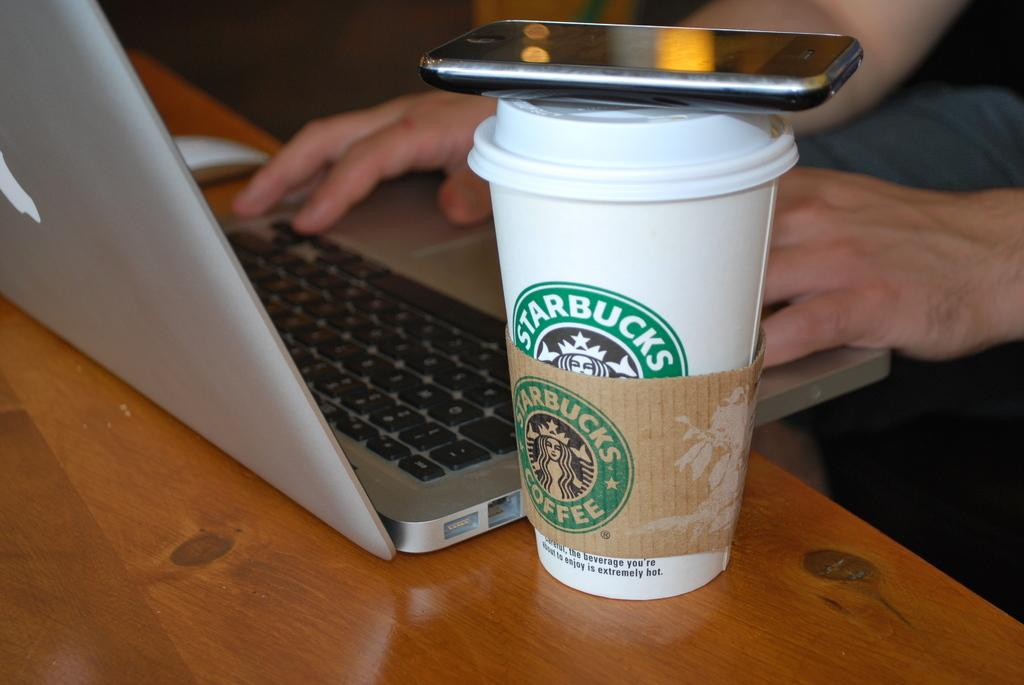<image>
Provide a brief description of the given image. someone using laptop with a phone on top of a starbucks cup next to it 